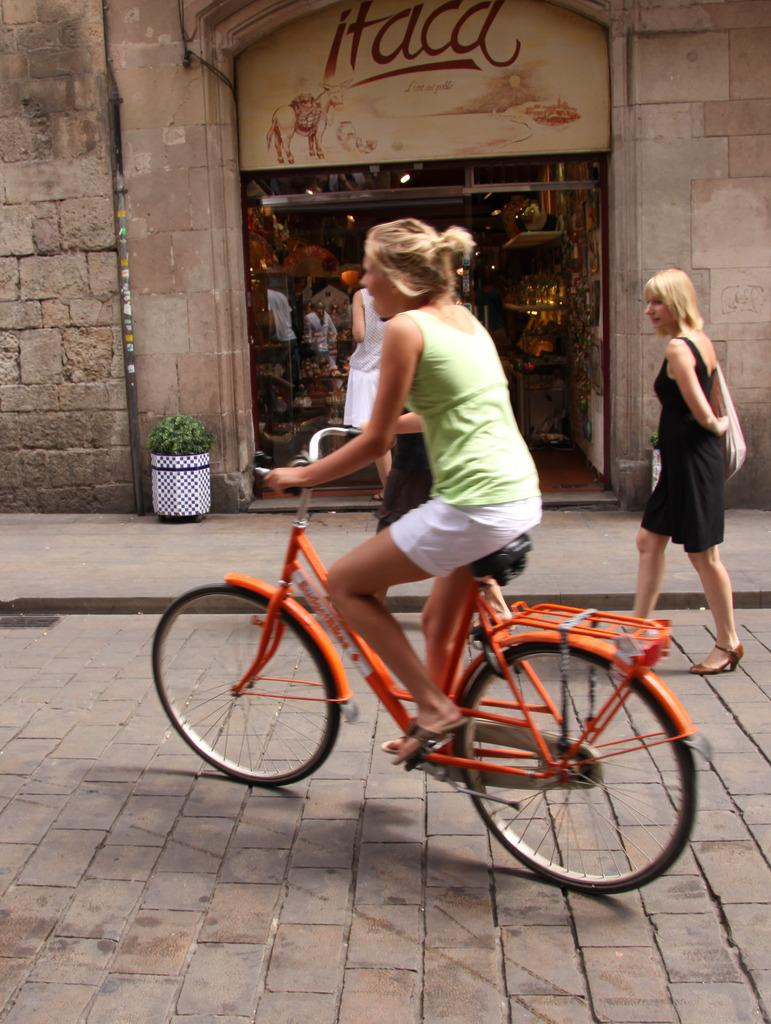What is the main subject of the image? There is a cycle in the image, and a woman is riding it. Who is accompanying the cyclist? There is another woman walking beside the cyclist. What can be seen in the background of the image? There is a store in the background of the image, and a wall beside the store. What type of plastic is covering the cyclist's toe in the image? There is no plastic or mention of a toe in the image; the cyclist is not wearing any plastic covering on their toe. 